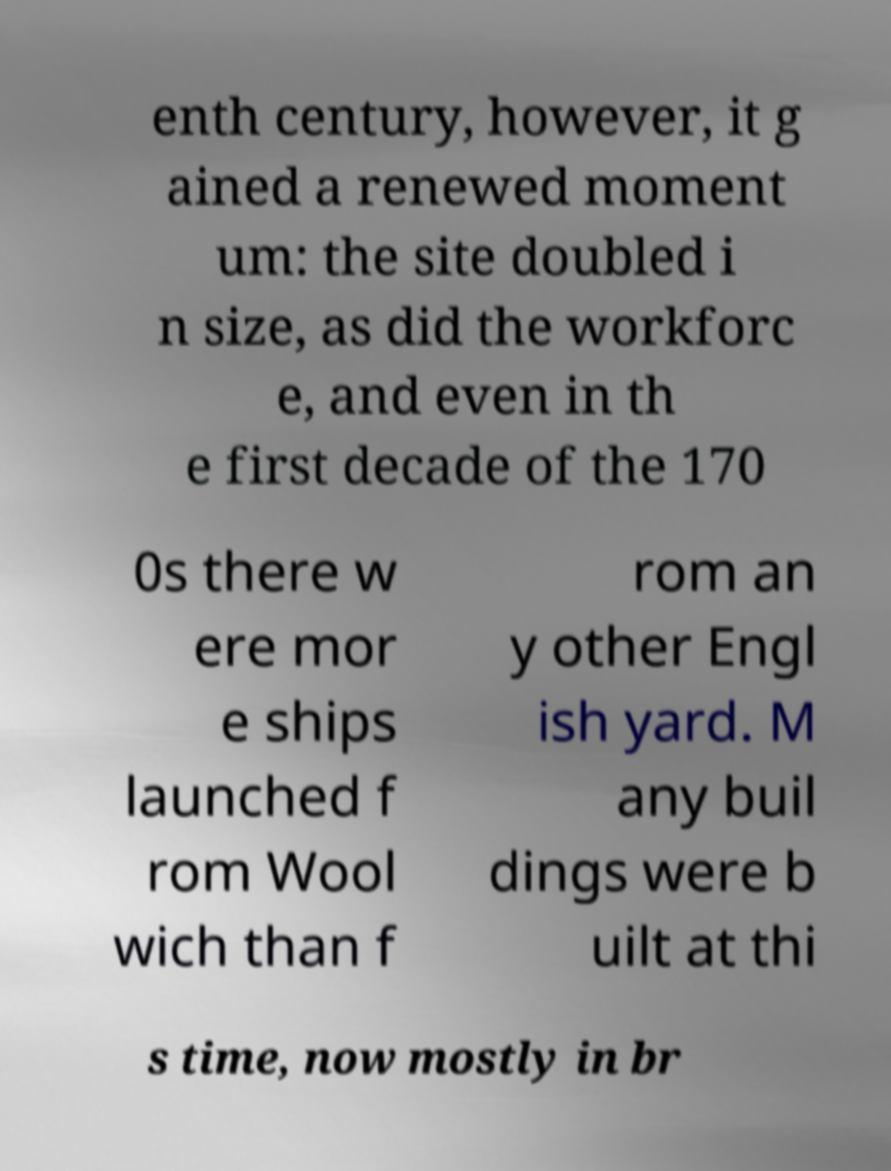Could you assist in decoding the text presented in this image and type it out clearly? enth century, however, it g ained a renewed moment um: the site doubled i n size, as did the workforc e, and even in th e first decade of the 170 0s there w ere mor e ships launched f rom Wool wich than f rom an y other Engl ish yard. M any buil dings were b uilt at thi s time, now mostly in br 